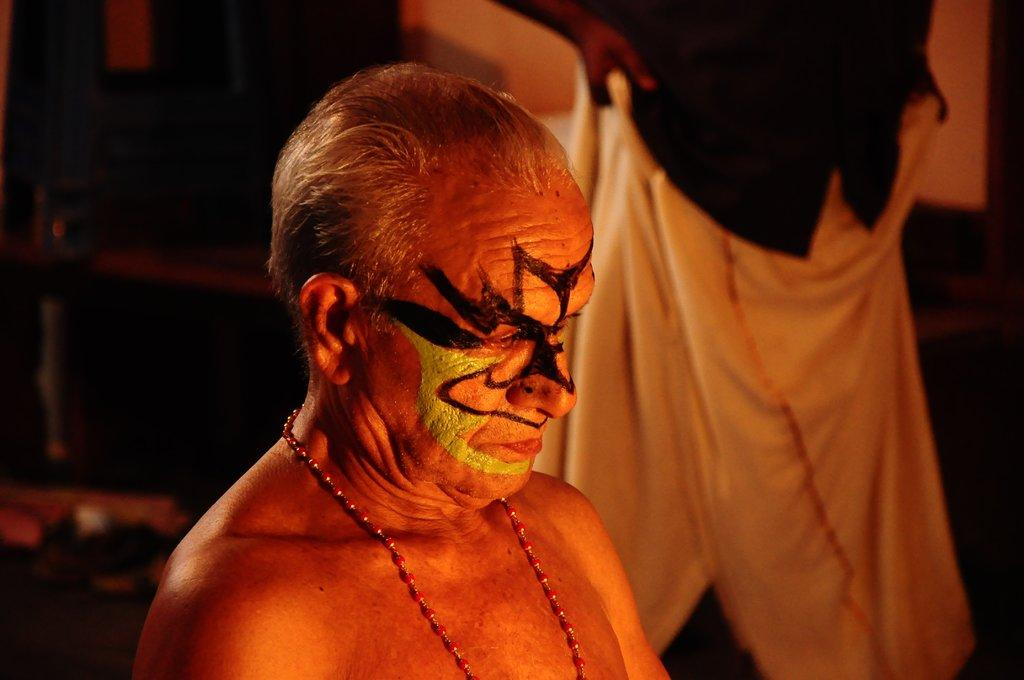Who is the main subject in the foreground of the image? There is a man in the foreground of the image. What can be observed on the man's face? The man has stretch marks on his face. Can you describe the person in the background of the image? There is another person standing in the background of the image. What color crayon is the man using to draw on his face in the image? There is no crayon present in the image, and the man does not appear to be drawing on his face. 